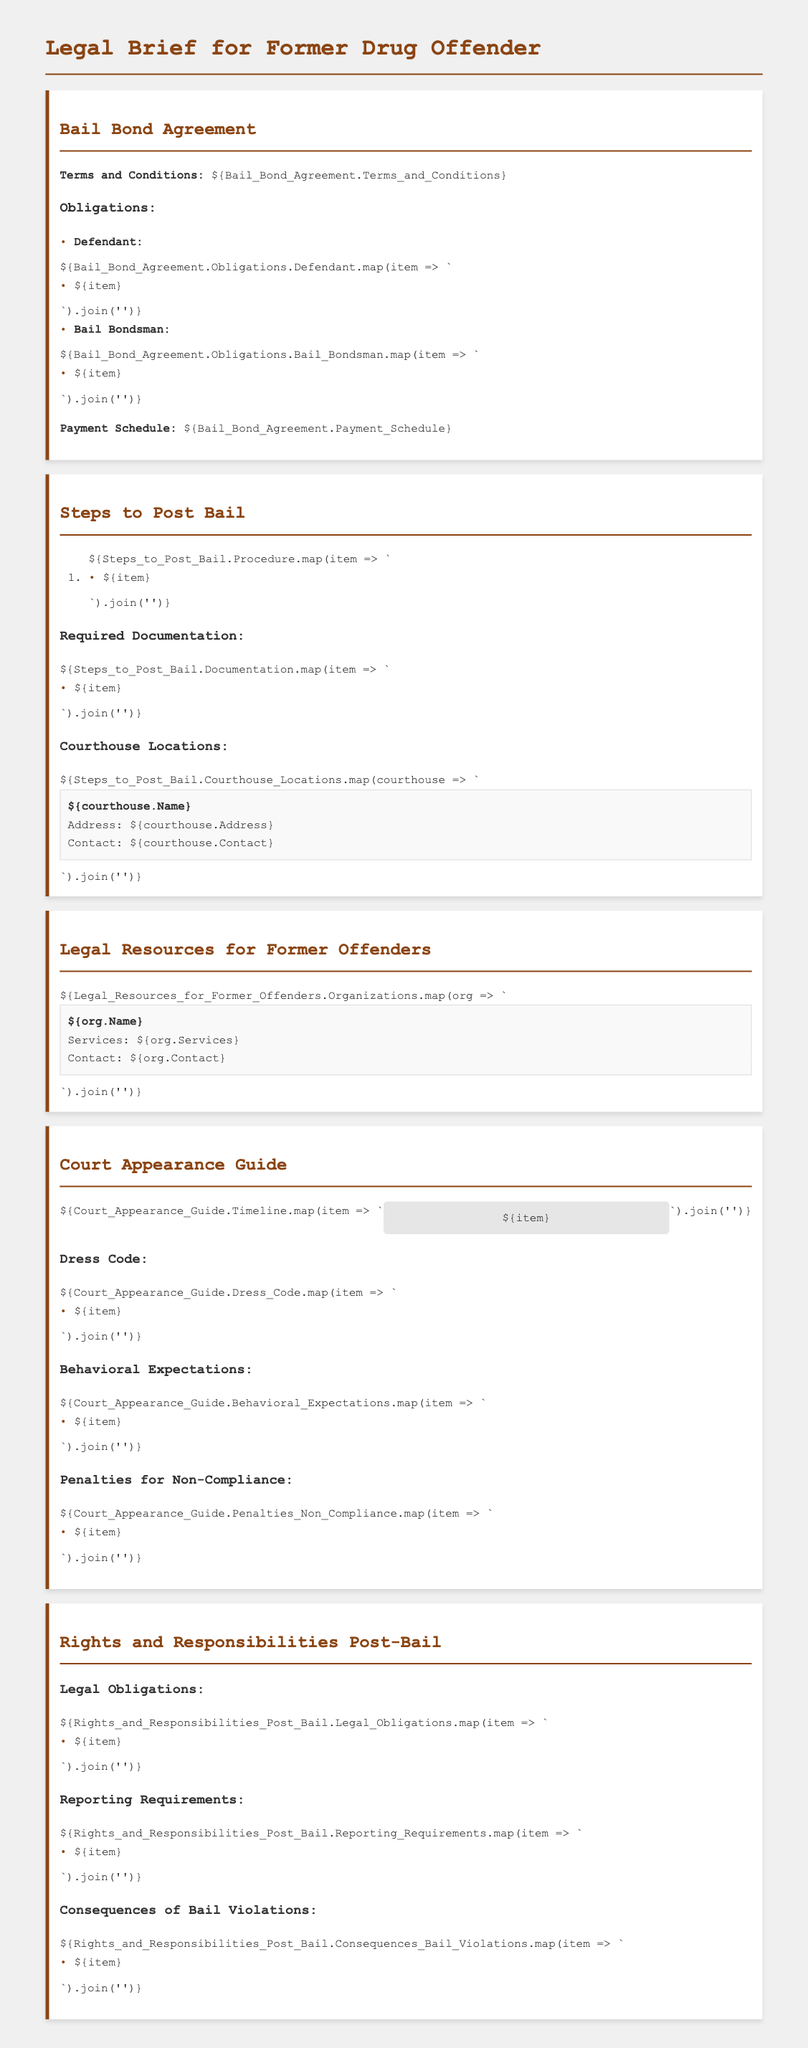What are the obligations of the defendant under the Bail Bond Agreement? The document lists the specific obligations of the defendant in the Bail Bond Agreement section, detailing what is expected from them.
Answer: [List of obligations] What is the payment schedule for the bail bond? The document provides details about the payment schedule related to the bail bond within the Bail Bond Agreement section.
Answer: [Payment Schedule] How many steps are there to post bail? The document outlines the procedural steps to post bail in a numbered list, providing a clear count of the steps involved.
Answer: [Number of steps] What is the dress code for court appearances? The document has a section that describes required attire or dress code for court appearances, which is important for compliance.
Answer: [Dress Code] What might happen if a defendant fails to comply with the court's expectations? The document includes a section outlining potential penalties for non-compliance with court rules, providing clarity on consequences.
Answer: [Penalties for Non-Compliance] Name one organization that offers legal resources for former offenders. The document specifies various organizations that assist former offenders, including their services, as part of the Legal Resources section.
Answer: [Organization Name] What are the reporting requirements post-bail? The document lists the specific reporting requirements that the defendant must adhere to after being released on bail.
Answer: [Reporting Requirements] What is included in the court appearance timeline? The document features a timeline of important court dates, which indicates significant events in the court process.
Answer: [Court Appearance Timeline] What are the legal obligations post-bail? The document lays out the legal obligations for individuals who have been released on bail, highlighting what they must fulfill.
Answer: [Legal Obligations] 